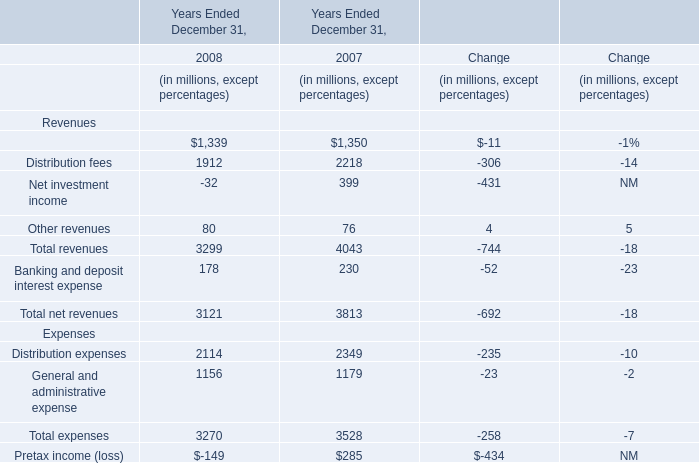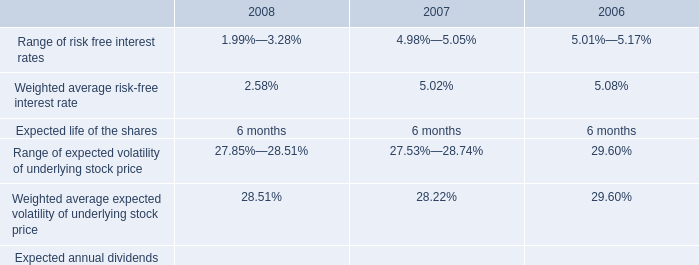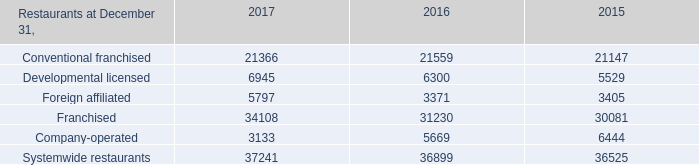Without distribution fees and other revenues, how much of revenues is there in total in 2008? (in dollars in millions) 
Computations: ((3299 - 1912) - 80)
Answer: 1307.0. 